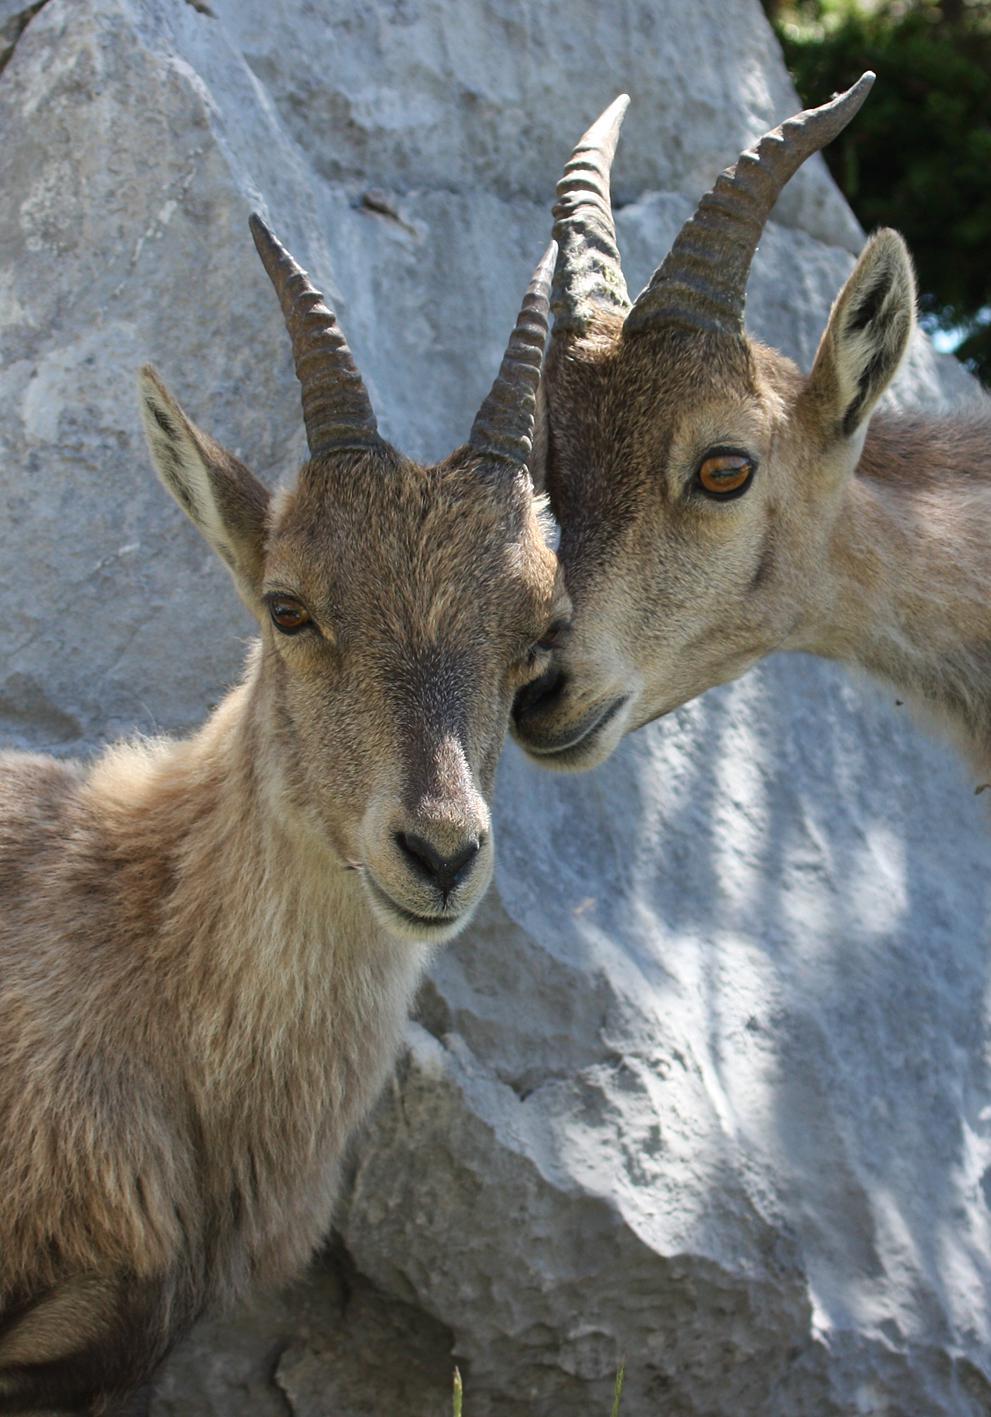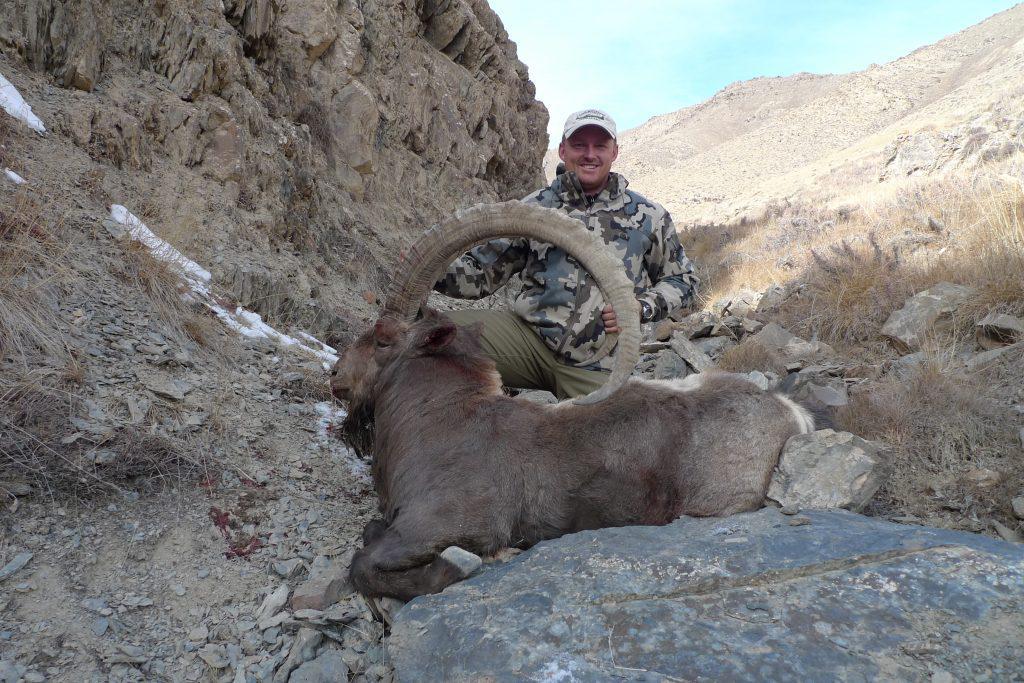The first image is the image on the left, the second image is the image on the right. Assess this claim about the two images: "An ibex has its front paws off the ground.". Correct or not? Answer yes or no. No. The first image is the image on the left, the second image is the image on the right. For the images shown, is this caption "There is at least one goat climbing a steep incline." true? Answer yes or no. No. 